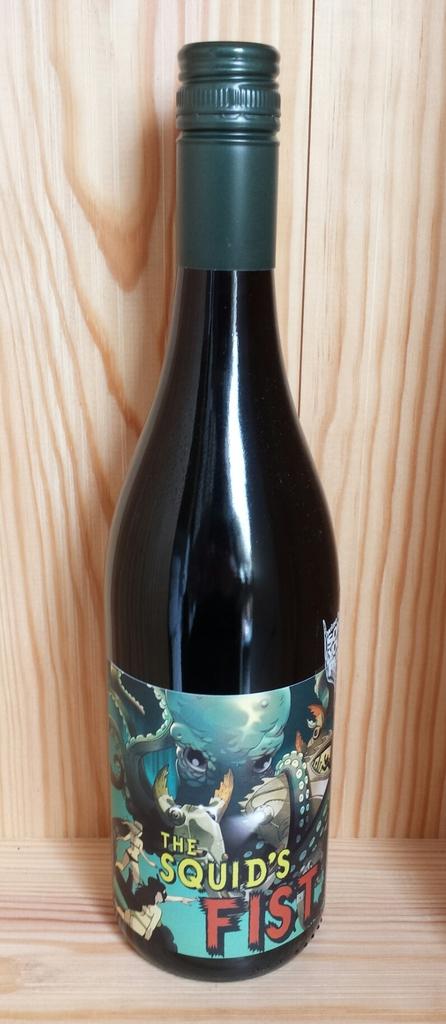What is the name of this wine?
Your answer should be compact. The squid's fist. 